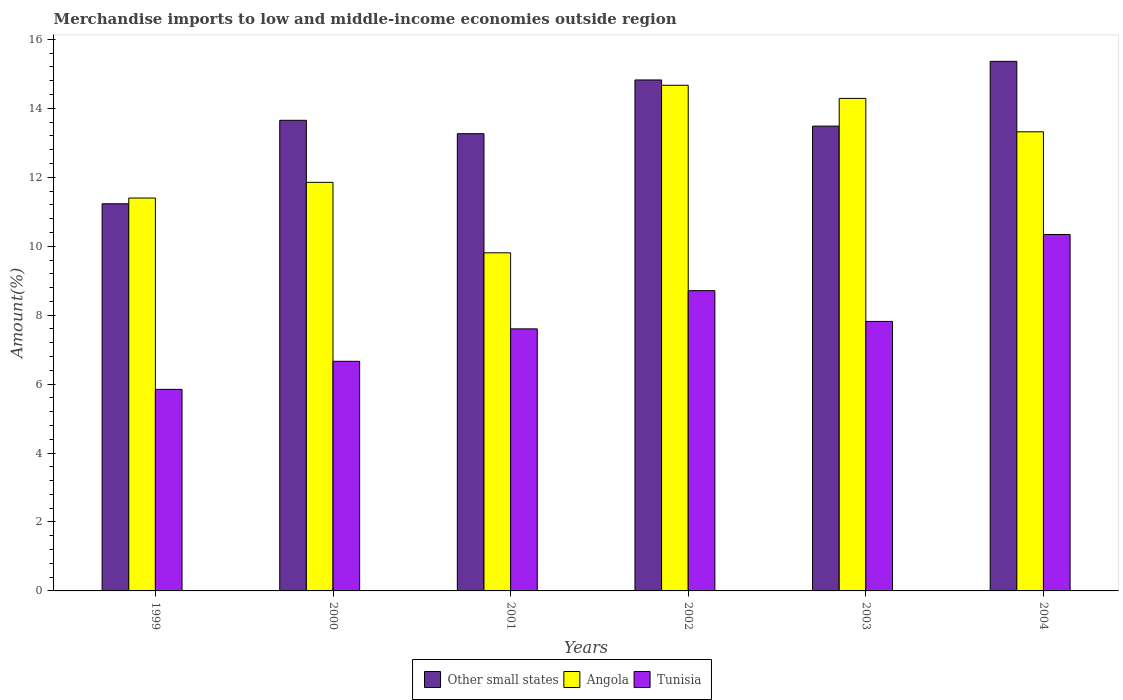How many different coloured bars are there?
Provide a short and direct response. 3. How many groups of bars are there?
Keep it short and to the point. 6. Are the number of bars per tick equal to the number of legend labels?
Your answer should be compact. Yes. What is the label of the 1st group of bars from the left?
Keep it short and to the point. 1999. What is the percentage of amount earned from merchandise imports in Other small states in 2004?
Your answer should be very brief. 15.36. Across all years, what is the maximum percentage of amount earned from merchandise imports in Tunisia?
Keep it short and to the point. 10.34. Across all years, what is the minimum percentage of amount earned from merchandise imports in Angola?
Your response must be concise. 9.81. What is the total percentage of amount earned from merchandise imports in Angola in the graph?
Keep it short and to the point. 75.33. What is the difference between the percentage of amount earned from merchandise imports in Angola in 1999 and that in 2002?
Offer a very short reply. -3.27. What is the difference between the percentage of amount earned from merchandise imports in Angola in 2003 and the percentage of amount earned from merchandise imports in Tunisia in 2001?
Offer a terse response. 6.69. What is the average percentage of amount earned from merchandise imports in Angola per year?
Provide a short and direct response. 12.56. In the year 2003, what is the difference between the percentage of amount earned from merchandise imports in Angola and percentage of amount earned from merchandise imports in Other small states?
Provide a short and direct response. 0.8. What is the ratio of the percentage of amount earned from merchandise imports in Tunisia in 2001 to that in 2003?
Offer a terse response. 0.97. What is the difference between the highest and the second highest percentage of amount earned from merchandise imports in Tunisia?
Offer a terse response. 1.63. What is the difference between the highest and the lowest percentage of amount earned from merchandise imports in Other small states?
Provide a short and direct response. 4.13. What does the 1st bar from the left in 2004 represents?
Keep it short and to the point. Other small states. What does the 1st bar from the right in 2002 represents?
Offer a terse response. Tunisia. Are the values on the major ticks of Y-axis written in scientific E-notation?
Give a very brief answer. No. How many legend labels are there?
Give a very brief answer. 3. How are the legend labels stacked?
Make the answer very short. Horizontal. What is the title of the graph?
Your answer should be very brief. Merchandise imports to low and middle-income economies outside region. What is the label or title of the Y-axis?
Offer a terse response. Amount(%). What is the Amount(%) of Other small states in 1999?
Keep it short and to the point. 11.23. What is the Amount(%) in Angola in 1999?
Offer a very short reply. 11.4. What is the Amount(%) in Tunisia in 1999?
Provide a succinct answer. 5.85. What is the Amount(%) of Other small states in 2000?
Give a very brief answer. 13.65. What is the Amount(%) of Angola in 2000?
Your answer should be very brief. 11.85. What is the Amount(%) of Tunisia in 2000?
Keep it short and to the point. 6.66. What is the Amount(%) in Other small states in 2001?
Your response must be concise. 13.26. What is the Amount(%) in Angola in 2001?
Provide a succinct answer. 9.81. What is the Amount(%) of Tunisia in 2001?
Provide a succinct answer. 7.6. What is the Amount(%) of Other small states in 2002?
Provide a short and direct response. 14.82. What is the Amount(%) in Angola in 2002?
Your answer should be compact. 14.67. What is the Amount(%) of Tunisia in 2002?
Offer a terse response. 8.71. What is the Amount(%) in Other small states in 2003?
Offer a very short reply. 13.48. What is the Amount(%) of Angola in 2003?
Make the answer very short. 14.29. What is the Amount(%) of Tunisia in 2003?
Keep it short and to the point. 7.82. What is the Amount(%) of Other small states in 2004?
Ensure brevity in your answer.  15.36. What is the Amount(%) in Angola in 2004?
Keep it short and to the point. 13.32. What is the Amount(%) of Tunisia in 2004?
Your answer should be compact. 10.34. Across all years, what is the maximum Amount(%) in Other small states?
Ensure brevity in your answer.  15.36. Across all years, what is the maximum Amount(%) of Angola?
Your answer should be very brief. 14.67. Across all years, what is the maximum Amount(%) in Tunisia?
Make the answer very short. 10.34. Across all years, what is the minimum Amount(%) in Other small states?
Provide a short and direct response. 11.23. Across all years, what is the minimum Amount(%) of Angola?
Give a very brief answer. 9.81. Across all years, what is the minimum Amount(%) of Tunisia?
Your response must be concise. 5.85. What is the total Amount(%) in Other small states in the graph?
Provide a succinct answer. 81.82. What is the total Amount(%) in Angola in the graph?
Ensure brevity in your answer.  75.33. What is the total Amount(%) of Tunisia in the graph?
Make the answer very short. 46.98. What is the difference between the Amount(%) in Other small states in 1999 and that in 2000?
Your answer should be compact. -2.42. What is the difference between the Amount(%) of Angola in 1999 and that in 2000?
Make the answer very short. -0.46. What is the difference between the Amount(%) of Tunisia in 1999 and that in 2000?
Offer a very short reply. -0.81. What is the difference between the Amount(%) of Other small states in 1999 and that in 2001?
Provide a short and direct response. -2.03. What is the difference between the Amount(%) of Angola in 1999 and that in 2001?
Your answer should be compact. 1.59. What is the difference between the Amount(%) of Tunisia in 1999 and that in 2001?
Keep it short and to the point. -1.75. What is the difference between the Amount(%) in Other small states in 1999 and that in 2002?
Your response must be concise. -3.59. What is the difference between the Amount(%) in Angola in 1999 and that in 2002?
Ensure brevity in your answer.  -3.27. What is the difference between the Amount(%) in Tunisia in 1999 and that in 2002?
Your answer should be compact. -2.86. What is the difference between the Amount(%) of Other small states in 1999 and that in 2003?
Offer a very short reply. -2.25. What is the difference between the Amount(%) in Angola in 1999 and that in 2003?
Your response must be concise. -2.89. What is the difference between the Amount(%) in Tunisia in 1999 and that in 2003?
Provide a succinct answer. -1.97. What is the difference between the Amount(%) of Other small states in 1999 and that in 2004?
Provide a succinct answer. -4.13. What is the difference between the Amount(%) in Angola in 1999 and that in 2004?
Your response must be concise. -1.92. What is the difference between the Amount(%) of Tunisia in 1999 and that in 2004?
Offer a very short reply. -4.49. What is the difference between the Amount(%) in Other small states in 2000 and that in 2001?
Ensure brevity in your answer.  0.39. What is the difference between the Amount(%) in Angola in 2000 and that in 2001?
Your answer should be very brief. 2.04. What is the difference between the Amount(%) of Tunisia in 2000 and that in 2001?
Your response must be concise. -0.94. What is the difference between the Amount(%) of Other small states in 2000 and that in 2002?
Offer a very short reply. -1.17. What is the difference between the Amount(%) of Angola in 2000 and that in 2002?
Give a very brief answer. -2.82. What is the difference between the Amount(%) of Tunisia in 2000 and that in 2002?
Give a very brief answer. -2.05. What is the difference between the Amount(%) of Other small states in 2000 and that in 2003?
Your answer should be compact. 0.17. What is the difference between the Amount(%) in Angola in 2000 and that in 2003?
Provide a short and direct response. -2.44. What is the difference between the Amount(%) of Tunisia in 2000 and that in 2003?
Provide a succinct answer. -1.16. What is the difference between the Amount(%) in Other small states in 2000 and that in 2004?
Ensure brevity in your answer.  -1.71. What is the difference between the Amount(%) in Angola in 2000 and that in 2004?
Ensure brevity in your answer.  -1.47. What is the difference between the Amount(%) in Tunisia in 2000 and that in 2004?
Ensure brevity in your answer.  -3.68. What is the difference between the Amount(%) in Other small states in 2001 and that in 2002?
Your answer should be very brief. -1.56. What is the difference between the Amount(%) in Angola in 2001 and that in 2002?
Offer a very short reply. -4.86. What is the difference between the Amount(%) of Tunisia in 2001 and that in 2002?
Give a very brief answer. -1.11. What is the difference between the Amount(%) of Other small states in 2001 and that in 2003?
Your response must be concise. -0.22. What is the difference between the Amount(%) of Angola in 2001 and that in 2003?
Ensure brevity in your answer.  -4.48. What is the difference between the Amount(%) in Tunisia in 2001 and that in 2003?
Provide a short and direct response. -0.22. What is the difference between the Amount(%) of Other small states in 2001 and that in 2004?
Offer a terse response. -2.1. What is the difference between the Amount(%) in Angola in 2001 and that in 2004?
Your answer should be compact. -3.51. What is the difference between the Amount(%) of Tunisia in 2001 and that in 2004?
Provide a succinct answer. -2.74. What is the difference between the Amount(%) in Other small states in 2002 and that in 2003?
Ensure brevity in your answer.  1.34. What is the difference between the Amount(%) of Angola in 2002 and that in 2003?
Make the answer very short. 0.38. What is the difference between the Amount(%) in Tunisia in 2002 and that in 2003?
Your answer should be compact. 0.89. What is the difference between the Amount(%) of Other small states in 2002 and that in 2004?
Give a very brief answer. -0.54. What is the difference between the Amount(%) of Angola in 2002 and that in 2004?
Offer a terse response. 1.35. What is the difference between the Amount(%) in Tunisia in 2002 and that in 2004?
Keep it short and to the point. -1.63. What is the difference between the Amount(%) of Other small states in 2003 and that in 2004?
Ensure brevity in your answer.  -1.88. What is the difference between the Amount(%) in Angola in 2003 and that in 2004?
Provide a succinct answer. 0.97. What is the difference between the Amount(%) in Tunisia in 2003 and that in 2004?
Make the answer very short. -2.52. What is the difference between the Amount(%) of Other small states in 1999 and the Amount(%) of Angola in 2000?
Your response must be concise. -0.62. What is the difference between the Amount(%) in Other small states in 1999 and the Amount(%) in Tunisia in 2000?
Make the answer very short. 4.57. What is the difference between the Amount(%) in Angola in 1999 and the Amount(%) in Tunisia in 2000?
Keep it short and to the point. 4.74. What is the difference between the Amount(%) of Other small states in 1999 and the Amount(%) of Angola in 2001?
Your answer should be compact. 1.42. What is the difference between the Amount(%) in Other small states in 1999 and the Amount(%) in Tunisia in 2001?
Ensure brevity in your answer.  3.63. What is the difference between the Amount(%) in Angola in 1999 and the Amount(%) in Tunisia in 2001?
Offer a terse response. 3.8. What is the difference between the Amount(%) in Other small states in 1999 and the Amount(%) in Angola in 2002?
Make the answer very short. -3.44. What is the difference between the Amount(%) in Other small states in 1999 and the Amount(%) in Tunisia in 2002?
Your answer should be compact. 2.52. What is the difference between the Amount(%) in Angola in 1999 and the Amount(%) in Tunisia in 2002?
Your answer should be very brief. 2.69. What is the difference between the Amount(%) in Other small states in 1999 and the Amount(%) in Angola in 2003?
Offer a terse response. -3.06. What is the difference between the Amount(%) of Other small states in 1999 and the Amount(%) of Tunisia in 2003?
Ensure brevity in your answer.  3.41. What is the difference between the Amount(%) in Angola in 1999 and the Amount(%) in Tunisia in 2003?
Offer a very short reply. 3.58. What is the difference between the Amount(%) in Other small states in 1999 and the Amount(%) in Angola in 2004?
Your response must be concise. -2.09. What is the difference between the Amount(%) in Other small states in 1999 and the Amount(%) in Tunisia in 2004?
Give a very brief answer. 0.89. What is the difference between the Amount(%) in Angola in 1999 and the Amount(%) in Tunisia in 2004?
Provide a succinct answer. 1.06. What is the difference between the Amount(%) in Other small states in 2000 and the Amount(%) in Angola in 2001?
Make the answer very short. 3.84. What is the difference between the Amount(%) of Other small states in 2000 and the Amount(%) of Tunisia in 2001?
Keep it short and to the point. 6.05. What is the difference between the Amount(%) in Angola in 2000 and the Amount(%) in Tunisia in 2001?
Make the answer very short. 4.25. What is the difference between the Amount(%) of Other small states in 2000 and the Amount(%) of Angola in 2002?
Keep it short and to the point. -1.02. What is the difference between the Amount(%) in Other small states in 2000 and the Amount(%) in Tunisia in 2002?
Give a very brief answer. 4.94. What is the difference between the Amount(%) of Angola in 2000 and the Amount(%) of Tunisia in 2002?
Keep it short and to the point. 3.14. What is the difference between the Amount(%) of Other small states in 2000 and the Amount(%) of Angola in 2003?
Your response must be concise. -0.64. What is the difference between the Amount(%) of Other small states in 2000 and the Amount(%) of Tunisia in 2003?
Provide a short and direct response. 5.83. What is the difference between the Amount(%) in Angola in 2000 and the Amount(%) in Tunisia in 2003?
Provide a short and direct response. 4.03. What is the difference between the Amount(%) of Other small states in 2000 and the Amount(%) of Angola in 2004?
Your answer should be compact. 0.33. What is the difference between the Amount(%) in Other small states in 2000 and the Amount(%) in Tunisia in 2004?
Offer a very short reply. 3.31. What is the difference between the Amount(%) of Angola in 2000 and the Amount(%) of Tunisia in 2004?
Ensure brevity in your answer.  1.51. What is the difference between the Amount(%) in Other small states in 2001 and the Amount(%) in Angola in 2002?
Your response must be concise. -1.4. What is the difference between the Amount(%) in Other small states in 2001 and the Amount(%) in Tunisia in 2002?
Ensure brevity in your answer.  4.55. What is the difference between the Amount(%) of Angola in 2001 and the Amount(%) of Tunisia in 2002?
Keep it short and to the point. 1.1. What is the difference between the Amount(%) in Other small states in 2001 and the Amount(%) in Angola in 2003?
Make the answer very short. -1.02. What is the difference between the Amount(%) of Other small states in 2001 and the Amount(%) of Tunisia in 2003?
Your answer should be very brief. 5.45. What is the difference between the Amount(%) of Angola in 2001 and the Amount(%) of Tunisia in 2003?
Offer a very short reply. 1.99. What is the difference between the Amount(%) in Other small states in 2001 and the Amount(%) in Angola in 2004?
Offer a terse response. -0.06. What is the difference between the Amount(%) of Other small states in 2001 and the Amount(%) of Tunisia in 2004?
Provide a succinct answer. 2.92. What is the difference between the Amount(%) in Angola in 2001 and the Amount(%) in Tunisia in 2004?
Ensure brevity in your answer.  -0.53. What is the difference between the Amount(%) of Other small states in 2002 and the Amount(%) of Angola in 2003?
Offer a terse response. 0.53. What is the difference between the Amount(%) in Other small states in 2002 and the Amount(%) in Tunisia in 2003?
Keep it short and to the point. 7.01. What is the difference between the Amount(%) in Angola in 2002 and the Amount(%) in Tunisia in 2003?
Your answer should be compact. 6.85. What is the difference between the Amount(%) of Other small states in 2002 and the Amount(%) of Angola in 2004?
Ensure brevity in your answer.  1.5. What is the difference between the Amount(%) in Other small states in 2002 and the Amount(%) in Tunisia in 2004?
Your answer should be compact. 4.48. What is the difference between the Amount(%) of Angola in 2002 and the Amount(%) of Tunisia in 2004?
Offer a very short reply. 4.33. What is the difference between the Amount(%) of Other small states in 2003 and the Amount(%) of Angola in 2004?
Make the answer very short. 0.17. What is the difference between the Amount(%) in Other small states in 2003 and the Amount(%) in Tunisia in 2004?
Give a very brief answer. 3.14. What is the difference between the Amount(%) of Angola in 2003 and the Amount(%) of Tunisia in 2004?
Give a very brief answer. 3.95. What is the average Amount(%) of Other small states per year?
Keep it short and to the point. 13.64. What is the average Amount(%) in Angola per year?
Give a very brief answer. 12.56. What is the average Amount(%) of Tunisia per year?
Provide a short and direct response. 7.83. In the year 1999, what is the difference between the Amount(%) in Other small states and Amount(%) in Angola?
Your response must be concise. -0.17. In the year 1999, what is the difference between the Amount(%) of Other small states and Amount(%) of Tunisia?
Provide a succinct answer. 5.38. In the year 1999, what is the difference between the Amount(%) of Angola and Amount(%) of Tunisia?
Make the answer very short. 5.55. In the year 2000, what is the difference between the Amount(%) of Other small states and Amount(%) of Angola?
Provide a short and direct response. 1.8. In the year 2000, what is the difference between the Amount(%) in Other small states and Amount(%) in Tunisia?
Your response must be concise. 6.99. In the year 2000, what is the difference between the Amount(%) in Angola and Amount(%) in Tunisia?
Your answer should be compact. 5.19. In the year 2001, what is the difference between the Amount(%) of Other small states and Amount(%) of Angola?
Your answer should be very brief. 3.46. In the year 2001, what is the difference between the Amount(%) of Other small states and Amount(%) of Tunisia?
Keep it short and to the point. 5.66. In the year 2001, what is the difference between the Amount(%) of Angola and Amount(%) of Tunisia?
Offer a terse response. 2.21. In the year 2002, what is the difference between the Amount(%) of Other small states and Amount(%) of Angola?
Offer a terse response. 0.15. In the year 2002, what is the difference between the Amount(%) in Other small states and Amount(%) in Tunisia?
Give a very brief answer. 6.11. In the year 2002, what is the difference between the Amount(%) of Angola and Amount(%) of Tunisia?
Your response must be concise. 5.96. In the year 2003, what is the difference between the Amount(%) of Other small states and Amount(%) of Angola?
Offer a terse response. -0.8. In the year 2003, what is the difference between the Amount(%) in Other small states and Amount(%) in Tunisia?
Make the answer very short. 5.67. In the year 2003, what is the difference between the Amount(%) of Angola and Amount(%) of Tunisia?
Offer a terse response. 6.47. In the year 2004, what is the difference between the Amount(%) in Other small states and Amount(%) in Angola?
Make the answer very short. 2.04. In the year 2004, what is the difference between the Amount(%) of Other small states and Amount(%) of Tunisia?
Ensure brevity in your answer.  5.02. In the year 2004, what is the difference between the Amount(%) in Angola and Amount(%) in Tunisia?
Your response must be concise. 2.98. What is the ratio of the Amount(%) of Other small states in 1999 to that in 2000?
Your answer should be very brief. 0.82. What is the ratio of the Amount(%) in Angola in 1999 to that in 2000?
Offer a terse response. 0.96. What is the ratio of the Amount(%) of Tunisia in 1999 to that in 2000?
Ensure brevity in your answer.  0.88. What is the ratio of the Amount(%) of Other small states in 1999 to that in 2001?
Make the answer very short. 0.85. What is the ratio of the Amount(%) in Angola in 1999 to that in 2001?
Your answer should be very brief. 1.16. What is the ratio of the Amount(%) of Tunisia in 1999 to that in 2001?
Provide a short and direct response. 0.77. What is the ratio of the Amount(%) of Other small states in 1999 to that in 2002?
Give a very brief answer. 0.76. What is the ratio of the Amount(%) of Angola in 1999 to that in 2002?
Your answer should be very brief. 0.78. What is the ratio of the Amount(%) in Tunisia in 1999 to that in 2002?
Give a very brief answer. 0.67. What is the ratio of the Amount(%) of Other small states in 1999 to that in 2003?
Provide a short and direct response. 0.83. What is the ratio of the Amount(%) in Angola in 1999 to that in 2003?
Provide a short and direct response. 0.8. What is the ratio of the Amount(%) in Tunisia in 1999 to that in 2003?
Ensure brevity in your answer.  0.75. What is the ratio of the Amount(%) of Other small states in 1999 to that in 2004?
Provide a short and direct response. 0.73. What is the ratio of the Amount(%) in Angola in 1999 to that in 2004?
Ensure brevity in your answer.  0.86. What is the ratio of the Amount(%) of Tunisia in 1999 to that in 2004?
Offer a terse response. 0.57. What is the ratio of the Amount(%) of Other small states in 2000 to that in 2001?
Your answer should be very brief. 1.03. What is the ratio of the Amount(%) of Angola in 2000 to that in 2001?
Ensure brevity in your answer.  1.21. What is the ratio of the Amount(%) of Tunisia in 2000 to that in 2001?
Give a very brief answer. 0.88. What is the ratio of the Amount(%) in Other small states in 2000 to that in 2002?
Your answer should be compact. 0.92. What is the ratio of the Amount(%) of Angola in 2000 to that in 2002?
Give a very brief answer. 0.81. What is the ratio of the Amount(%) of Tunisia in 2000 to that in 2002?
Your response must be concise. 0.76. What is the ratio of the Amount(%) in Other small states in 2000 to that in 2003?
Offer a terse response. 1.01. What is the ratio of the Amount(%) in Angola in 2000 to that in 2003?
Give a very brief answer. 0.83. What is the ratio of the Amount(%) in Tunisia in 2000 to that in 2003?
Ensure brevity in your answer.  0.85. What is the ratio of the Amount(%) of Other small states in 2000 to that in 2004?
Your response must be concise. 0.89. What is the ratio of the Amount(%) in Angola in 2000 to that in 2004?
Ensure brevity in your answer.  0.89. What is the ratio of the Amount(%) in Tunisia in 2000 to that in 2004?
Make the answer very short. 0.64. What is the ratio of the Amount(%) of Other small states in 2001 to that in 2002?
Give a very brief answer. 0.89. What is the ratio of the Amount(%) of Angola in 2001 to that in 2002?
Give a very brief answer. 0.67. What is the ratio of the Amount(%) of Tunisia in 2001 to that in 2002?
Provide a succinct answer. 0.87. What is the ratio of the Amount(%) in Other small states in 2001 to that in 2003?
Ensure brevity in your answer.  0.98. What is the ratio of the Amount(%) of Angola in 2001 to that in 2003?
Give a very brief answer. 0.69. What is the ratio of the Amount(%) in Tunisia in 2001 to that in 2003?
Your answer should be very brief. 0.97. What is the ratio of the Amount(%) of Other small states in 2001 to that in 2004?
Make the answer very short. 0.86. What is the ratio of the Amount(%) of Angola in 2001 to that in 2004?
Your answer should be compact. 0.74. What is the ratio of the Amount(%) in Tunisia in 2001 to that in 2004?
Provide a short and direct response. 0.74. What is the ratio of the Amount(%) in Other small states in 2002 to that in 2003?
Keep it short and to the point. 1.1. What is the ratio of the Amount(%) in Angola in 2002 to that in 2003?
Keep it short and to the point. 1.03. What is the ratio of the Amount(%) in Tunisia in 2002 to that in 2003?
Make the answer very short. 1.11. What is the ratio of the Amount(%) in Other small states in 2002 to that in 2004?
Give a very brief answer. 0.96. What is the ratio of the Amount(%) in Angola in 2002 to that in 2004?
Keep it short and to the point. 1.1. What is the ratio of the Amount(%) in Tunisia in 2002 to that in 2004?
Keep it short and to the point. 0.84. What is the ratio of the Amount(%) of Other small states in 2003 to that in 2004?
Provide a short and direct response. 0.88. What is the ratio of the Amount(%) in Angola in 2003 to that in 2004?
Provide a succinct answer. 1.07. What is the ratio of the Amount(%) in Tunisia in 2003 to that in 2004?
Give a very brief answer. 0.76. What is the difference between the highest and the second highest Amount(%) of Other small states?
Make the answer very short. 0.54. What is the difference between the highest and the second highest Amount(%) in Angola?
Provide a short and direct response. 0.38. What is the difference between the highest and the second highest Amount(%) of Tunisia?
Your answer should be compact. 1.63. What is the difference between the highest and the lowest Amount(%) in Other small states?
Your answer should be compact. 4.13. What is the difference between the highest and the lowest Amount(%) in Angola?
Your answer should be very brief. 4.86. What is the difference between the highest and the lowest Amount(%) of Tunisia?
Give a very brief answer. 4.49. 